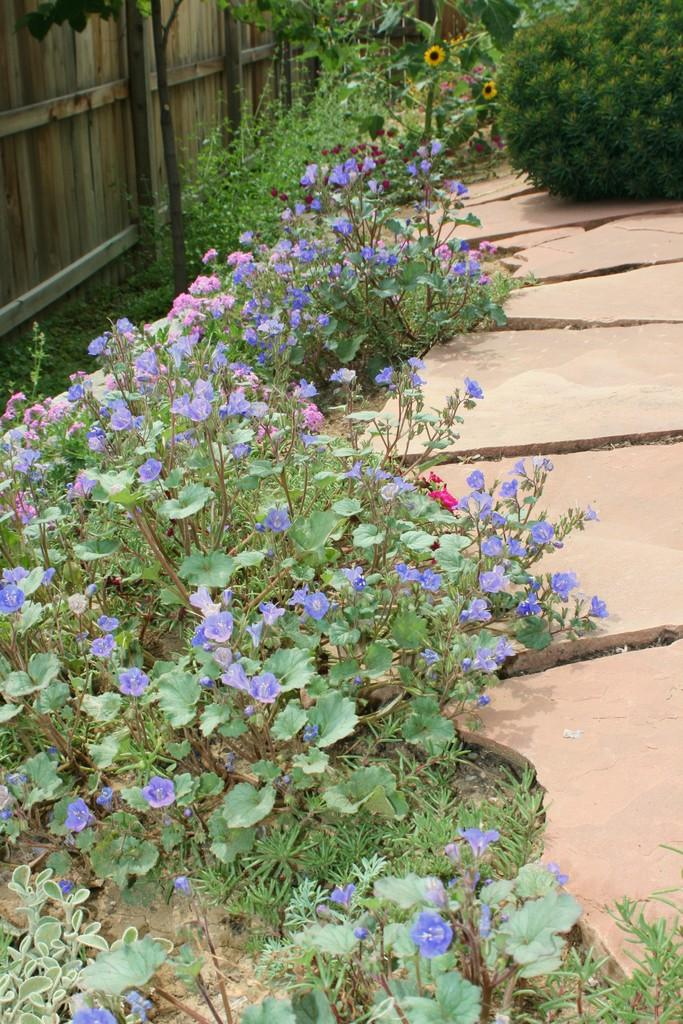What celestial bodies are depicted in the image? There are planets in the image. What type of path can be seen in the image? There is a path in the image. What type of vegetation is present in the image? There is grass in the image. What type of fence is visible in the image? There is a wooden fence in the image. What type of band is playing music in the image? There is no band present in the image; it features planets, a path, grass, and a wooden fence. How many steps are visible in the image? There are no steps visible in the image. 